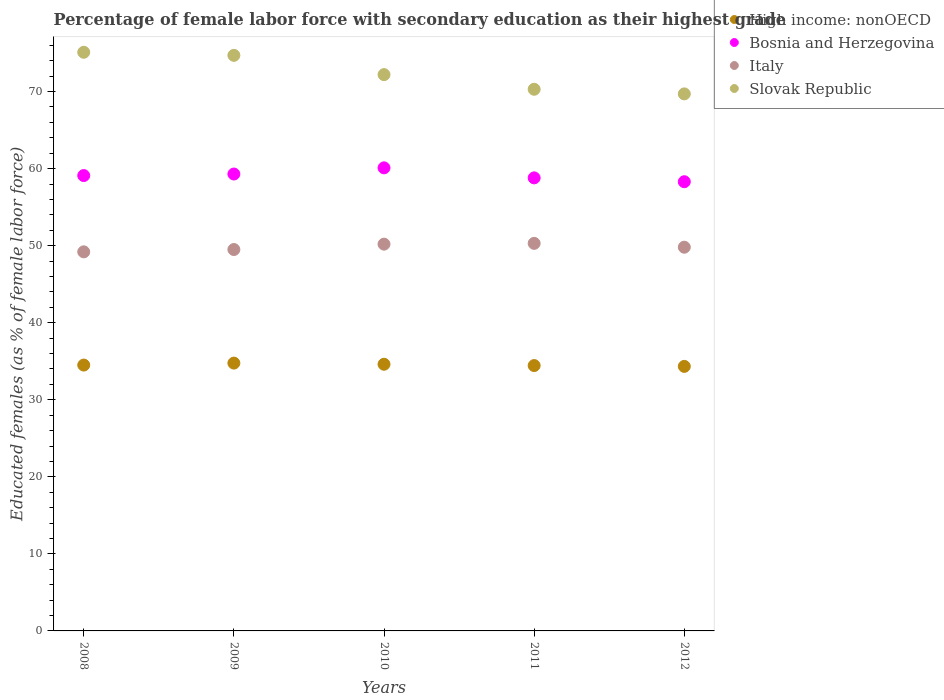How many different coloured dotlines are there?
Offer a very short reply. 4. Is the number of dotlines equal to the number of legend labels?
Provide a succinct answer. Yes. What is the percentage of female labor force with secondary education in Italy in 2010?
Provide a succinct answer. 50.2. Across all years, what is the maximum percentage of female labor force with secondary education in Italy?
Your response must be concise. 50.3. Across all years, what is the minimum percentage of female labor force with secondary education in High income: nonOECD?
Provide a short and direct response. 34.33. In which year was the percentage of female labor force with secondary education in Italy maximum?
Your response must be concise. 2011. What is the total percentage of female labor force with secondary education in High income: nonOECD in the graph?
Your answer should be compact. 172.65. What is the difference between the percentage of female labor force with secondary education in High income: nonOECD in 2012 and the percentage of female labor force with secondary education in Bosnia and Herzegovina in 2009?
Provide a short and direct response. -24.97. What is the average percentage of female labor force with secondary education in Slovak Republic per year?
Your response must be concise. 72.4. In the year 2011, what is the difference between the percentage of female labor force with secondary education in Slovak Republic and percentage of female labor force with secondary education in Bosnia and Herzegovina?
Ensure brevity in your answer.  11.5. In how many years, is the percentage of female labor force with secondary education in High income: nonOECD greater than 8 %?
Offer a terse response. 5. What is the ratio of the percentage of female labor force with secondary education in Bosnia and Herzegovina in 2008 to that in 2011?
Keep it short and to the point. 1.01. Is the percentage of female labor force with secondary education in High income: nonOECD in 2011 less than that in 2012?
Keep it short and to the point. No. What is the difference between the highest and the second highest percentage of female labor force with secondary education in Italy?
Make the answer very short. 0.1. What is the difference between the highest and the lowest percentage of female labor force with secondary education in Slovak Republic?
Provide a short and direct response. 5.4. Is the sum of the percentage of female labor force with secondary education in Slovak Republic in 2008 and 2010 greater than the maximum percentage of female labor force with secondary education in Italy across all years?
Give a very brief answer. Yes. Is it the case that in every year, the sum of the percentage of female labor force with secondary education in High income: nonOECD and percentage of female labor force with secondary education in Slovak Republic  is greater than the sum of percentage of female labor force with secondary education in Bosnia and Herzegovina and percentage of female labor force with secondary education in Italy?
Provide a succinct answer. No. Is it the case that in every year, the sum of the percentage of female labor force with secondary education in Slovak Republic and percentage of female labor force with secondary education in Italy  is greater than the percentage of female labor force with secondary education in Bosnia and Herzegovina?
Your response must be concise. Yes. Does the percentage of female labor force with secondary education in Slovak Republic monotonically increase over the years?
Offer a very short reply. No. How many years are there in the graph?
Ensure brevity in your answer.  5. What is the difference between two consecutive major ticks on the Y-axis?
Your answer should be compact. 10. Are the values on the major ticks of Y-axis written in scientific E-notation?
Offer a very short reply. No. Does the graph contain grids?
Ensure brevity in your answer.  No. How many legend labels are there?
Provide a succinct answer. 4. How are the legend labels stacked?
Your answer should be compact. Vertical. What is the title of the graph?
Make the answer very short. Percentage of female labor force with secondary education as their highest grade. Does "Rwanda" appear as one of the legend labels in the graph?
Your response must be concise. No. What is the label or title of the X-axis?
Your answer should be very brief. Years. What is the label or title of the Y-axis?
Your response must be concise. Educated females (as % of female labor force). What is the Educated females (as % of female labor force) in High income: nonOECD in 2008?
Provide a succinct answer. 34.51. What is the Educated females (as % of female labor force) in Bosnia and Herzegovina in 2008?
Provide a short and direct response. 59.1. What is the Educated females (as % of female labor force) in Italy in 2008?
Offer a terse response. 49.2. What is the Educated females (as % of female labor force) in Slovak Republic in 2008?
Ensure brevity in your answer.  75.1. What is the Educated females (as % of female labor force) in High income: nonOECD in 2009?
Keep it short and to the point. 34.76. What is the Educated females (as % of female labor force) in Bosnia and Herzegovina in 2009?
Keep it short and to the point. 59.3. What is the Educated females (as % of female labor force) of Italy in 2009?
Provide a short and direct response. 49.5. What is the Educated females (as % of female labor force) of Slovak Republic in 2009?
Give a very brief answer. 74.7. What is the Educated females (as % of female labor force) in High income: nonOECD in 2010?
Provide a short and direct response. 34.61. What is the Educated females (as % of female labor force) of Bosnia and Herzegovina in 2010?
Make the answer very short. 60.1. What is the Educated females (as % of female labor force) of Italy in 2010?
Your answer should be compact. 50.2. What is the Educated females (as % of female labor force) in Slovak Republic in 2010?
Provide a short and direct response. 72.2. What is the Educated females (as % of female labor force) in High income: nonOECD in 2011?
Keep it short and to the point. 34.44. What is the Educated females (as % of female labor force) in Bosnia and Herzegovina in 2011?
Offer a terse response. 58.8. What is the Educated females (as % of female labor force) in Italy in 2011?
Give a very brief answer. 50.3. What is the Educated females (as % of female labor force) in Slovak Republic in 2011?
Ensure brevity in your answer.  70.3. What is the Educated females (as % of female labor force) of High income: nonOECD in 2012?
Ensure brevity in your answer.  34.33. What is the Educated females (as % of female labor force) of Bosnia and Herzegovina in 2012?
Provide a succinct answer. 58.3. What is the Educated females (as % of female labor force) in Italy in 2012?
Ensure brevity in your answer.  49.8. What is the Educated females (as % of female labor force) of Slovak Republic in 2012?
Give a very brief answer. 69.7. Across all years, what is the maximum Educated females (as % of female labor force) of High income: nonOECD?
Provide a succinct answer. 34.76. Across all years, what is the maximum Educated females (as % of female labor force) of Bosnia and Herzegovina?
Offer a terse response. 60.1. Across all years, what is the maximum Educated females (as % of female labor force) in Italy?
Provide a succinct answer. 50.3. Across all years, what is the maximum Educated females (as % of female labor force) in Slovak Republic?
Your answer should be compact. 75.1. Across all years, what is the minimum Educated females (as % of female labor force) of High income: nonOECD?
Ensure brevity in your answer.  34.33. Across all years, what is the minimum Educated females (as % of female labor force) in Bosnia and Herzegovina?
Your response must be concise. 58.3. Across all years, what is the minimum Educated females (as % of female labor force) in Italy?
Offer a very short reply. 49.2. Across all years, what is the minimum Educated females (as % of female labor force) in Slovak Republic?
Make the answer very short. 69.7. What is the total Educated females (as % of female labor force) of High income: nonOECD in the graph?
Keep it short and to the point. 172.65. What is the total Educated females (as % of female labor force) of Bosnia and Herzegovina in the graph?
Give a very brief answer. 295.6. What is the total Educated females (as % of female labor force) in Italy in the graph?
Give a very brief answer. 249. What is the total Educated females (as % of female labor force) in Slovak Republic in the graph?
Offer a very short reply. 362. What is the difference between the Educated females (as % of female labor force) of High income: nonOECD in 2008 and that in 2009?
Your answer should be compact. -0.25. What is the difference between the Educated females (as % of female labor force) in High income: nonOECD in 2008 and that in 2010?
Ensure brevity in your answer.  -0.11. What is the difference between the Educated females (as % of female labor force) of High income: nonOECD in 2008 and that in 2011?
Provide a succinct answer. 0.07. What is the difference between the Educated females (as % of female labor force) of Bosnia and Herzegovina in 2008 and that in 2011?
Provide a succinct answer. 0.3. What is the difference between the Educated females (as % of female labor force) in Italy in 2008 and that in 2011?
Offer a very short reply. -1.1. What is the difference between the Educated females (as % of female labor force) of High income: nonOECD in 2008 and that in 2012?
Offer a very short reply. 0.17. What is the difference between the Educated females (as % of female labor force) in Bosnia and Herzegovina in 2008 and that in 2012?
Provide a short and direct response. 0.8. What is the difference between the Educated females (as % of female labor force) in Slovak Republic in 2008 and that in 2012?
Offer a terse response. 5.4. What is the difference between the Educated females (as % of female labor force) in High income: nonOECD in 2009 and that in 2010?
Provide a short and direct response. 0.15. What is the difference between the Educated females (as % of female labor force) of High income: nonOECD in 2009 and that in 2011?
Make the answer very short. 0.32. What is the difference between the Educated females (as % of female labor force) of Bosnia and Herzegovina in 2009 and that in 2011?
Ensure brevity in your answer.  0.5. What is the difference between the Educated females (as % of female labor force) of Italy in 2009 and that in 2011?
Provide a succinct answer. -0.8. What is the difference between the Educated females (as % of female labor force) in High income: nonOECD in 2009 and that in 2012?
Your answer should be very brief. 0.42. What is the difference between the Educated females (as % of female labor force) in Bosnia and Herzegovina in 2009 and that in 2012?
Give a very brief answer. 1. What is the difference between the Educated females (as % of female labor force) in High income: nonOECD in 2010 and that in 2011?
Provide a succinct answer. 0.17. What is the difference between the Educated females (as % of female labor force) of Italy in 2010 and that in 2011?
Your answer should be compact. -0.1. What is the difference between the Educated females (as % of female labor force) in Slovak Republic in 2010 and that in 2011?
Your answer should be compact. 1.9. What is the difference between the Educated females (as % of female labor force) of High income: nonOECD in 2010 and that in 2012?
Make the answer very short. 0.28. What is the difference between the Educated females (as % of female labor force) of Italy in 2010 and that in 2012?
Your answer should be compact. 0.4. What is the difference between the Educated females (as % of female labor force) of Slovak Republic in 2010 and that in 2012?
Give a very brief answer. 2.5. What is the difference between the Educated females (as % of female labor force) of High income: nonOECD in 2011 and that in 2012?
Provide a short and direct response. 0.11. What is the difference between the Educated females (as % of female labor force) of Bosnia and Herzegovina in 2011 and that in 2012?
Offer a very short reply. 0.5. What is the difference between the Educated females (as % of female labor force) of Italy in 2011 and that in 2012?
Ensure brevity in your answer.  0.5. What is the difference between the Educated females (as % of female labor force) in Slovak Republic in 2011 and that in 2012?
Your answer should be very brief. 0.6. What is the difference between the Educated females (as % of female labor force) in High income: nonOECD in 2008 and the Educated females (as % of female labor force) in Bosnia and Herzegovina in 2009?
Provide a short and direct response. -24.79. What is the difference between the Educated females (as % of female labor force) of High income: nonOECD in 2008 and the Educated females (as % of female labor force) of Italy in 2009?
Your answer should be very brief. -14.99. What is the difference between the Educated females (as % of female labor force) in High income: nonOECD in 2008 and the Educated females (as % of female labor force) in Slovak Republic in 2009?
Make the answer very short. -40.19. What is the difference between the Educated females (as % of female labor force) in Bosnia and Herzegovina in 2008 and the Educated females (as % of female labor force) in Italy in 2009?
Provide a succinct answer. 9.6. What is the difference between the Educated females (as % of female labor force) of Bosnia and Herzegovina in 2008 and the Educated females (as % of female labor force) of Slovak Republic in 2009?
Your answer should be very brief. -15.6. What is the difference between the Educated females (as % of female labor force) in Italy in 2008 and the Educated females (as % of female labor force) in Slovak Republic in 2009?
Offer a terse response. -25.5. What is the difference between the Educated females (as % of female labor force) of High income: nonOECD in 2008 and the Educated females (as % of female labor force) of Bosnia and Herzegovina in 2010?
Make the answer very short. -25.59. What is the difference between the Educated females (as % of female labor force) in High income: nonOECD in 2008 and the Educated females (as % of female labor force) in Italy in 2010?
Provide a succinct answer. -15.69. What is the difference between the Educated females (as % of female labor force) of High income: nonOECD in 2008 and the Educated females (as % of female labor force) of Slovak Republic in 2010?
Give a very brief answer. -37.69. What is the difference between the Educated females (as % of female labor force) in High income: nonOECD in 2008 and the Educated females (as % of female labor force) in Bosnia and Herzegovina in 2011?
Your response must be concise. -24.29. What is the difference between the Educated females (as % of female labor force) of High income: nonOECD in 2008 and the Educated females (as % of female labor force) of Italy in 2011?
Offer a very short reply. -15.79. What is the difference between the Educated females (as % of female labor force) of High income: nonOECD in 2008 and the Educated females (as % of female labor force) of Slovak Republic in 2011?
Offer a very short reply. -35.79. What is the difference between the Educated females (as % of female labor force) of Italy in 2008 and the Educated females (as % of female labor force) of Slovak Republic in 2011?
Give a very brief answer. -21.1. What is the difference between the Educated females (as % of female labor force) in High income: nonOECD in 2008 and the Educated females (as % of female labor force) in Bosnia and Herzegovina in 2012?
Give a very brief answer. -23.79. What is the difference between the Educated females (as % of female labor force) in High income: nonOECD in 2008 and the Educated females (as % of female labor force) in Italy in 2012?
Keep it short and to the point. -15.29. What is the difference between the Educated females (as % of female labor force) of High income: nonOECD in 2008 and the Educated females (as % of female labor force) of Slovak Republic in 2012?
Offer a terse response. -35.19. What is the difference between the Educated females (as % of female labor force) in Bosnia and Herzegovina in 2008 and the Educated females (as % of female labor force) in Slovak Republic in 2012?
Make the answer very short. -10.6. What is the difference between the Educated females (as % of female labor force) of Italy in 2008 and the Educated females (as % of female labor force) of Slovak Republic in 2012?
Offer a terse response. -20.5. What is the difference between the Educated females (as % of female labor force) in High income: nonOECD in 2009 and the Educated females (as % of female labor force) in Bosnia and Herzegovina in 2010?
Ensure brevity in your answer.  -25.34. What is the difference between the Educated females (as % of female labor force) of High income: nonOECD in 2009 and the Educated females (as % of female labor force) of Italy in 2010?
Your response must be concise. -15.44. What is the difference between the Educated females (as % of female labor force) of High income: nonOECD in 2009 and the Educated females (as % of female labor force) of Slovak Republic in 2010?
Offer a very short reply. -37.44. What is the difference between the Educated females (as % of female labor force) of Italy in 2009 and the Educated females (as % of female labor force) of Slovak Republic in 2010?
Your answer should be compact. -22.7. What is the difference between the Educated females (as % of female labor force) in High income: nonOECD in 2009 and the Educated females (as % of female labor force) in Bosnia and Herzegovina in 2011?
Your answer should be very brief. -24.04. What is the difference between the Educated females (as % of female labor force) in High income: nonOECD in 2009 and the Educated females (as % of female labor force) in Italy in 2011?
Offer a terse response. -15.54. What is the difference between the Educated females (as % of female labor force) in High income: nonOECD in 2009 and the Educated females (as % of female labor force) in Slovak Republic in 2011?
Offer a terse response. -35.54. What is the difference between the Educated females (as % of female labor force) of Italy in 2009 and the Educated females (as % of female labor force) of Slovak Republic in 2011?
Give a very brief answer. -20.8. What is the difference between the Educated females (as % of female labor force) of High income: nonOECD in 2009 and the Educated females (as % of female labor force) of Bosnia and Herzegovina in 2012?
Your answer should be very brief. -23.54. What is the difference between the Educated females (as % of female labor force) of High income: nonOECD in 2009 and the Educated females (as % of female labor force) of Italy in 2012?
Provide a short and direct response. -15.04. What is the difference between the Educated females (as % of female labor force) in High income: nonOECD in 2009 and the Educated females (as % of female labor force) in Slovak Republic in 2012?
Your response must be concise. -34.94. What is the difference between the Educated females (as % of female labor force) in Bosnia and Herzegovina in 2009 and the Educated females (as % of female labor force) in Italy in 2012?
Give a very brief answer. 9.5. What is the difference between the Educated females (as % of female labor force) of Bosnia and Herzegovina in 2009 and the Educated females (as % of female labor force) of Slovak Republic in 2012?
Ensure brevity in your answer.  -10.4. What is the difference between the Educated females (as % of female labor force) in Italy in 2009 and the Educated females (as % of female labor force) in Slovak Republic in 2012?
Keep it short and to the point. -20.2. What is the difference between the Educated females (as % of female labor force) in High income: nonOECD in 2010 and the Educated females (as % of female labor force) in Bosnia and Herzegovina in 2011?
Your answer should be compact. -24.19. What is the difference between the Educated females (as % of female labor force) of High income: nonOECD in 2010 and the Educated females (as % of female labor force) of Italy in 2011?
Your response must be concise. -15.69. What is the difference between the Educated females (as % of female labor force) in High income: nonOECD in 2010 and the Educated females (as % of female labor force) in Slovak Republic in 2011?
Make the answer very short. -35.69. What is the difference between the Educated females (as % of female labor force) of Bosnia and Herzegovina in 2010 and the Educated females (as % of female labor force) of Italy in 2011?
Provide a succinct answer. 9.8. What is the difference between the Educated females (as % of female labor force) in Bosnia and Herzegovina in 2010 and the Educated females (as % of female labor force) in Slovak Republic in 2011?
Keep it short and to the point. -10.2. What is the difference between the Educated females (as % of female labor force) of Italy in 2010 and the Educated females (as % of female labor force) of Slovak Republic in 2011?
Your answer should be very brief. -20.1. What is the difference between the Educated females (as % of female labor force) in High income: nonOECD in 2010 and the Educated females (as % of female labor force) in Bosnia and Herzegovina in 2012?
Provide a succinct answer. -23.69. What is the difference between the Educated females (as % of female labor force) in High income: nonOECD in 2010 and the Educated females (as % of female labor force) in Italy in 2012?
Keep it short and to the point. -15.19. What is the difference between the Educated females (as % of female labor force) in High income: nonOECD in 2010 and the Educated females (as % of female labor force) in Slovak Republic in 2012?
Offer a terse response. -35.09. What is the difference between the Educated females (as % of female labor force) in Bosnia and Herzegovina in 2010 and the Educated females (as % of female labor force) in Slovak Republic in 2012?
Ensure brevity in your answer.  -9.6. What is the difference between the Educated females (as % of female labor force) of Italy in 2010 and the Educated females (as % of female labor force) of Slovak Republic in 2012?
Your answer should be compact. -19.5. What is the difference between the Educated females (as % of female labor force) in High income: nonOECD in 2011 and the Educated females (as % of female labor force) in Bosnia and Herzegovina in 2012?
Offer a terse response. -23.86. What is the difference between the Educated females (as % of female labor force) in High income: nonOECD in 2011 and the Educated females (as % of female labor force) in Italy in 2012?
Give a very brief answer. -15.36. What is the difference between the Educated females (as % of female labor force) in High income: nonOECD in 2011 and the Educated females (as % of female labor force) in Slovak Republic in 2012?
Give a very brief answer. -35.26. What is the difference between the Educated females (as % of female labor force) of Bosnia and Herzegovina in 2011 and the Educated females (as % of female labor force) of Italy in 2012?
Offer a terse response. 9. What is the difference between the Educated females (as % of female labor force) in Bosnia and Herzegovina in 2011 and the Educated females (as % of female labor force) in Slovak Republic in 2012?
Provide a short and direct response. -10.9. What is the difference between the Educated females (as % of female labor force) in Italy in 2011 and the Educated females (as % of female labor force) in Slovak Republic in 2012?
Provide a succinct answer. -19.4. What is the average Educated females (as % of female labor force) of High income: nonOECD per year?
Make the answer very short. 34.53. What is the average Educated females (as % of female labor force) of Bosnia and Herzegovina per year?
Provide a succinct answer. 59.12. What is the average Educated females (as % of female labor force) of Italy per year?
Provide a succinct answer. 49.8. What is the average Educated females (as % of female labor force) in Slovak Republic per year?
Keep it short and to the point. 72.4. In the year 2008, what is the difference between the Educated females (as % of female labor force) in High income: nonOECD and Educated females (as % of female labor force) in Bosnia and Herzegovina?
Give a very brief answer. -24.59. In the year 2008, what is the difference between the Educated females (as % of female labor force) in High income: nonOECD and Educated females (as % of female labor force) in Italy?
Your response must be concise. -14.69. In the year 2008, what is the difference between the Educated females (as % of female labor force) in High income: nonOECD and Educated females (as % of female labor force) in Slovak Republic?
Ensure brevity in your answer.  -40.59. In the year 2008, what is the difference between the Educated females (as % of female labor force) in Italy and Educated females (as % of female labor force) in Slovak Republic?
Ensure brevity in your answer.  -25.9. In the year 2009, what is the difference between the Educated females (as % of female labor force) of High income: nonOECD and Educated females (as % of female labor force) of Bosnia and Herzegovina?
Offer a very short reply. -24.54. In the year 2009, what is the difference between the Educated females (as % of female labor force) in High income: nonOECD and Educated females (as % of female labor force) in Italy?
Offer a terse response. -14.74. In the year 2009, what is the difference between the Educated females (as % of female labor force) in High income: nonOECD and Educated females (as % of female labor force) in Slovak Republic?
Give a very brief answer. -39.94. In the year 2009, what is the difference between the Educated females (as % of female labor force) of Bosnia and Herzegovina and Educated females (as % of female labor force) of Slovak Republic?
Give a very brief answer. -15.4. In the year 2009, what is the difference between the Educated females (as % of female labor force) of Italy and Educated females (as % of female labor force) of Slovak Republic?
Offer a very short reply. -25.2. In the year 2010, what is the difference between the Educated females (as % of female labor force) in High income: nonOECD and Educated females (as % of female labor force) in Bosnia and Herzegovina?
Your answer should be very brief. -25.49. In the year 2010, what is the difference between the Educated females (as % of female labor force) in High income: nonOECD and Educated females (as % of female labor force) in Italy?
Your response must be concise. -15.59. In the year 2010, what is the difference between the Educated females (as % of female labor force) of High income: nonOECD and Educated females (as % of female labor force) of Slovak Republic?
Give a very brief answer. -37.59. In the year 2010, what is the difference between the Educated females (as % of female labor force) in Bosnia and Herzegovina and Educated females (as % of female labor force) in Slovak Republic?
Make the answer very short. -12.1. In the year 2010, what is the difference between the Educated females (as % of female labor force) in Italy and Educated females (as % of female labor force) in Slovak Republic?
Offer a terse response. -22. In the year 2011, what is the difference between the Educated females (as % of female labor force) of High income: nonOECD and Educated females (as % of female labor force) of Bosnia and Herzegovina?
Your answer should be very brief. -24.36. In the year 2011, what is the difference between the Educated females (as % of female labor force) in High income: nonOECD and Educated females (as % of female labor force) in Italy?
Provide a succinct answer. -15.86. In the year 2011, what is the difference between the Educated females (as % of female labor force) of High income: nonOECD and Educated females (as % of female labor force) of Slovak Republic?
Make the answer very short. -35.86. In the year 2011, what is the difference between the Educated females (as % of female labor force) in Bosnia and Herzegovina and Educated females (as % of female labor force) in Italy?
Your answer should be compact. 8.5. In the year 2011, what is the difference between the Educated females (as % of female labor force) in Italy and Educated females (as % of female labor force) in Slovak Republic?
Your answer should be compact. -20. In the year 2012, what is the difference between the Educated females (as % of female labor force) in High income: nonOECD and Educated females (as % of female labor force) in Bosnia and Herzegovina?
Offer a very short reply. -23.97. In the year 2012, what is the difference between the Educated females (as % of female labor force) in High income: nonOECD and Educated females (as % of female labor force) in Italy?
Your response must be concise. -15.47. In the year 2012, what is the difference between the Educated females (as % of female labor force) in High income: nonOECD and Educated females (as % of female labor force) in Slovak Republic?
Your answer should be very brief. -35.37. In the year 2012, what is the difference between the Educated females (as % of female labor force) in Bosnia and Herzegovina and Educated females (as % of female labor force) in Slovak Republic?
Make the answer very short. -11.4. In the year 2012, what is the difference between the Educated females (as % of female labor force) in Italy and Educated females (as % of female labor force) in Slovak Republic?
Make the answer very short. -19.9. What is the ratio of the Educated females (as % of female labor force) in High income: nonOECD in 2008 to that in 2009?
Your answer should be very brief. 0.99. What is the ratio of the Educated females (as % of female labor force) of Italy in 2008 to that in 2009?
Give a very brief answer. 0.99. What is the ratio of the Educated females (as % of female labor force) of Slovak Republic in 2008 to that in 2009?
Your response must be concise. 1.01. What is the ratio of the Educated females (as % of female labor force) of High income: nonOECD in 2008 to that in 2010?
Make the answer very short. 1. What is the ratio of the Educated females (as % of female labor force) of Bosnia and Herzegovina in 2008 to that in 2010?
Provide a succinct answer. 0.98. What is the ratio of the Educated females (as % of female labor force) in Italy in 2008 to that in 2010?
Your response must be concise. 0.98. What is the ratio of the Educated females (as % of female labor force) in Slovak Republic in 2008 to that in 2010?
Provide a short and direct response. 1.04. What is the ratio of the Educated females (as % of female labor force) in Bosnia and Herzegovina in 2008 to that in 2011?
Your response must be concise. 1.01. What is the ratio of the Educated females (as % of female labor force) in Italy in 2008 to that in 2011?
Your answer should be compact. 0.98. What is the ratio of the Educated females (as % of female labor force) in Slovak Republic in 2008 to that in 2011?
Offer a terse response. 1.07. What is the ratio of the Educated females (as % of female labor force) in High income: nonOECD in 2008 to that in 2012?
Make the answer very short. 1. What is the ratio of the Educated females (as % of female labor force) of Bosnia and Herzegovina in 2008 to that in 2012?
Your answer should be compact. 1.01. What is the ratio of the Educated females (as % of female labor force) in Italy in 2008 to that in 2012?
Make the answer very short. 0.99. What is the ratio of the Educated females (as % of female labor force) in Slovak Republic in 2008 to that in 2012?
Provide a succinct answer. 1.08. What is the ratio of the Educated females (as % of female labor force) of Bosnia and Herzegovina in 2009 to that in 2010?
Your answer should be very brief. 0.99. What is the ratio of the Educated females (as % of female labor force) of Italy in 2009 to that in 2010?
Your response must be concise. 0.99. What is the ratio of the Educated females (as % of female labor force) of Slovak Republic in 2009 to that in 2010?
Ensure brevity in your answer.  1.03. What is the ratio of the Educated females (as % of female labor force) in High income: nonOECD in 2009 to that in 2011?
Offer a very short reply. 1.01. What is the ratio of the Educated females (as % of female labor force) of Bosnia and Herzegovina in 2009 to that in 2011?
Provide a succinct answer. 1.01. What is the ratio of the Educated females (as % of female labor force) of Italy in 2009 to that in 2011?
Keep it short and to the point. 0.98. What is the ratio of the Educated females (as % of female labor force) of Slovak Republic in 2009 to that in 2011?
Make the answer very short. 1.06. What is the ratio of the Educated females (as % of female labor force) in High income: nonOECD in 2009 to that in 2012?
Offer a terse response. 1.01. What is the ratio of the Educated females (as % of female labor force) in Bosnia and Herzegovina in 2009 to that in 2012?
Your response must be concise. 1.02. What is the ratio of the Educated females (as % of female labor force) of Italy in 2009 to that in 2012?
Make the answer very short. 0.99. What is the ratio of the Educated females (as % of female labor force) in Slovak Republic in 2009 to that in 2012?
Offer a very short reply. 1.07. What is the ratio of the Educated females (as % of female labor force) of Bosnia and Herzegovina in 2010 to that in 2011?
Ensure brevity in your answer.  1.02. What is the ratio of the Educated females (as % of female labor force) of Italy in 2010 to that in 2011?
Offer a terse response. 1. What is the ratio of the Educated females (as % of female labor force) in Bosnia and Herzegovina in 2010 to that in 2012?
Provide a succinct answer. 1.03. What is the ratio of the Educated females (as % of female labor force) in Italy in 2010 to that in 2012?
Give a very brief answer. 1.01. What is the ratio of the Educated females (as % of female labor force) of Slovak Republic in 2010 to that in 2012?
Your answer should be very brief. 1.04. What is the ratio of the Educated females (as % of female labor force) in Bosnia and Herzegovina in 2011 to that in 2012?
Offer a terse response. 1.01. What is the ratio of the Educated females (as % of female labor force) in Italy in 2011 to that in 2012?
Ensure brevity in your answer.  1.01. What is the ratio of the Educated females (as % of female labor force) of Slovak Republic in 2011 to that in 2012?
Keep it short and to the point. 1.01. What is the difference between the highest and the second highest Educated females (as % of female labor force) of High income: nonOECD?
Offer a terse response. 0.15. What is the difference between the highest and the lowest Educated females (as % of female labor force) in High income: nonOECD?
Give a very brief answer. 0.42. What is the difference between the highest and the lowest Educated females (as % of female labor force) of Italy?
Your answer should be very brief. 1.1. 